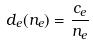<formula> <loc_0><loc_0><loc_500><loc_500>d _ { e } ( n _ { e } ) = \frac { c _ { e } } { n _ { e } }</formula> 